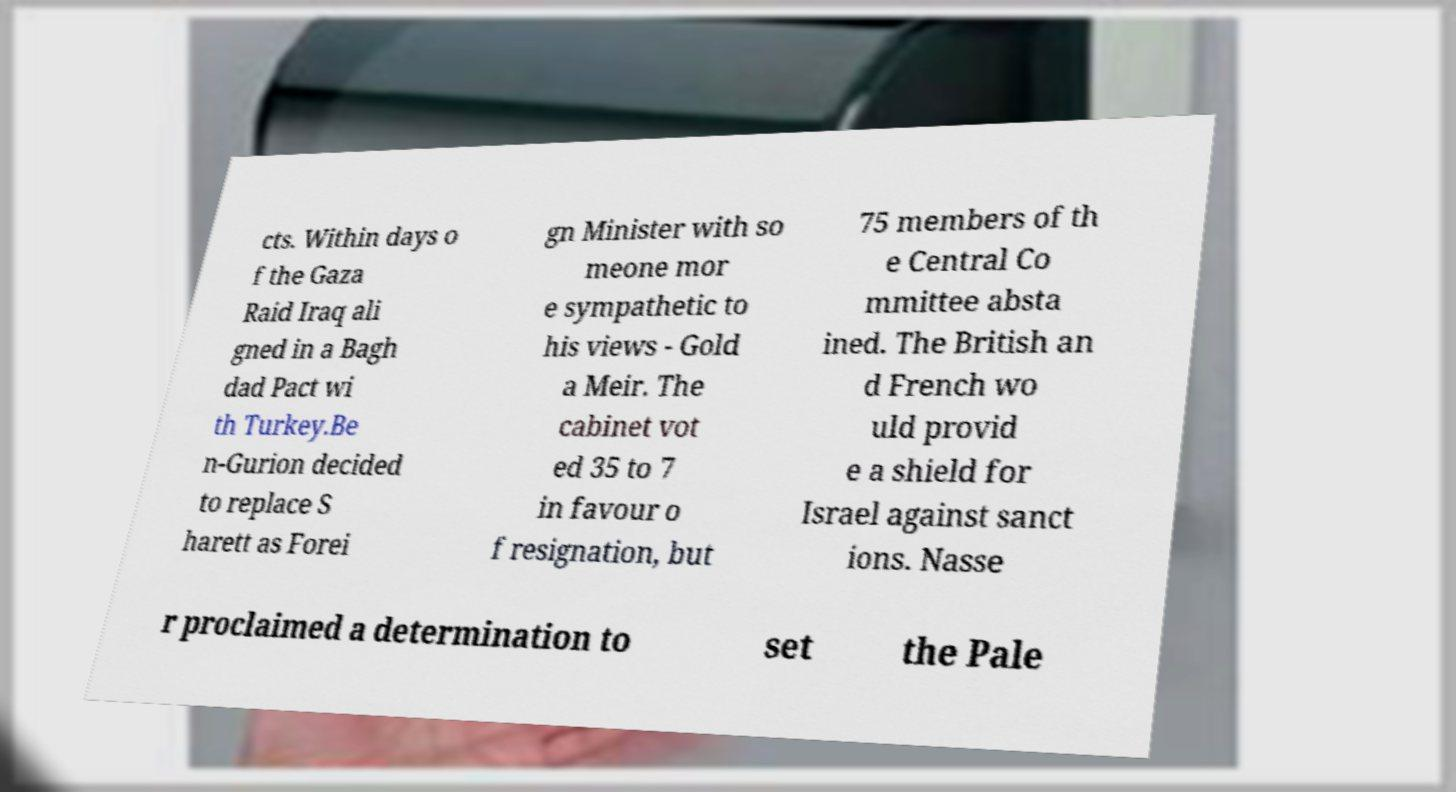I need the written content from this picture converted into text. Can you do that? cts. Within days o f the Gaza Raid Iraq ali gned in a Bagh dad Pact wi th Turkey.Be n-Gurion decided to replace S harett as Forei gn Minister with so meone mor e sympathetic to his views - Gold a Meir. The cabinet vot ed 35 to 7 in favour o f resignation, but 75 members of th e Central Co mmittee absta ined. The British an d French wo uld provid e a shield for Israel against sanct ions. Nasse r proclaimed a determination to set the Pale 